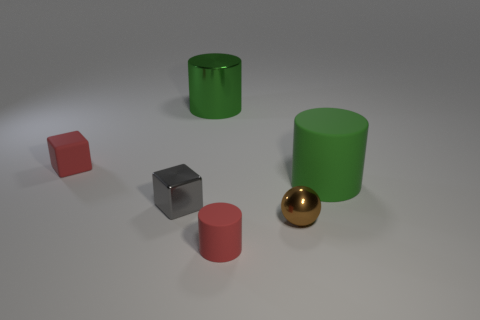Add 2 yellow cubes. How many objects exist? 8 Subtract all spheres. How many objects are left? 5 Subtract all tiny metal blocks. Subtract all large green shiny cylinders. How many objects are left? 4 Add 5 big rubber cylinders. How many big rubber cylinders are left? 6 Add 3 tiny gray balls. How many tiny gray balls exist? 3 Subtract 1 brown balls. How many objects are left? 5 